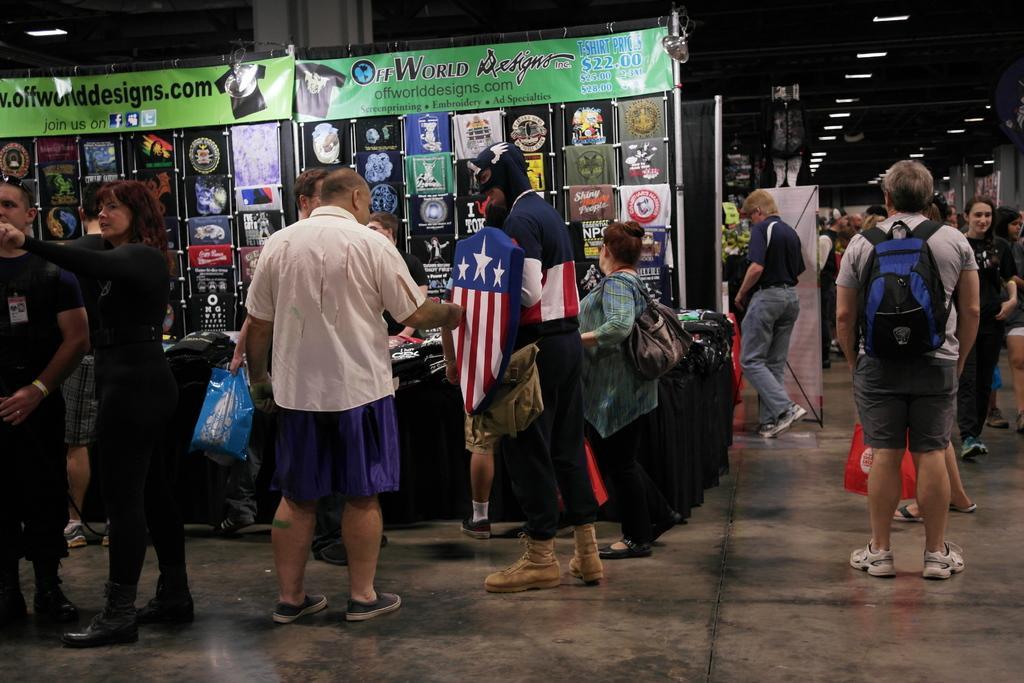Can you describe this image briefly? In this picture there is a man who is wearing white shirt, short and shoe. Beside him we can see a person who is wearing a captain america's dress and holding a shield. On the left there is a woman who is wearing black dress, beside her we can see a man who is also wearing a black dress. Behind them we can see the table and banners. On the right we can see a man who is wearing a bag. In the background we can see the group of persons were walking on the street. Beside them we can see the shop and banner. At the top we can see the tube lights. 